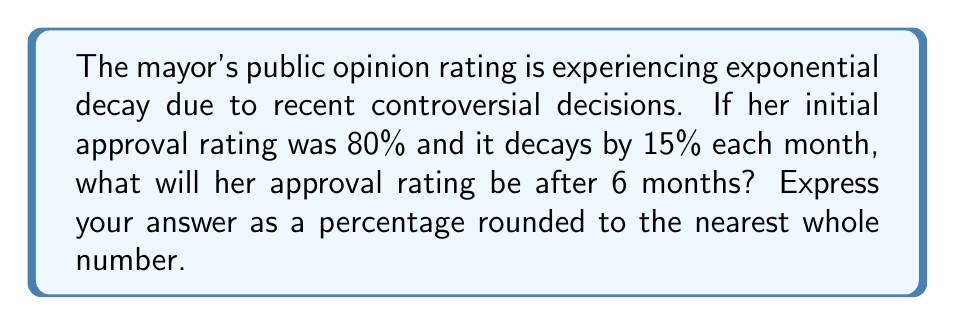Could you help me with this problem? Let's approach this step-by-step:

1) The initial approval rating is 80%, and it decays by 15% each month.
   This means that each month, the rating is multiplied by (1 - 0.15) = 0.85.

2) We can represent this exponential decay using the formula:
   $A(t) = A_0 \cdot (1-r)^t$
   Where:
   $A(t)$ is the approval rating after time $t$
   $A_0$ is the initial approval rating
   $r$ is the decay rate
   $t$ is the number of time periods (months in this case)

3) Plugging in our values:
   $A(6) = 80 \cdot (0.85)^6$

4) Now let's calculate:
   $A(6) = 80 \cdot (0.85)^6$
   $    = 80 \cdot 0.377628$
   $    = 30.21024$

5) Rounding to the nearest whole number:
   30.21024 ≈ 30%
Answer: 30% 